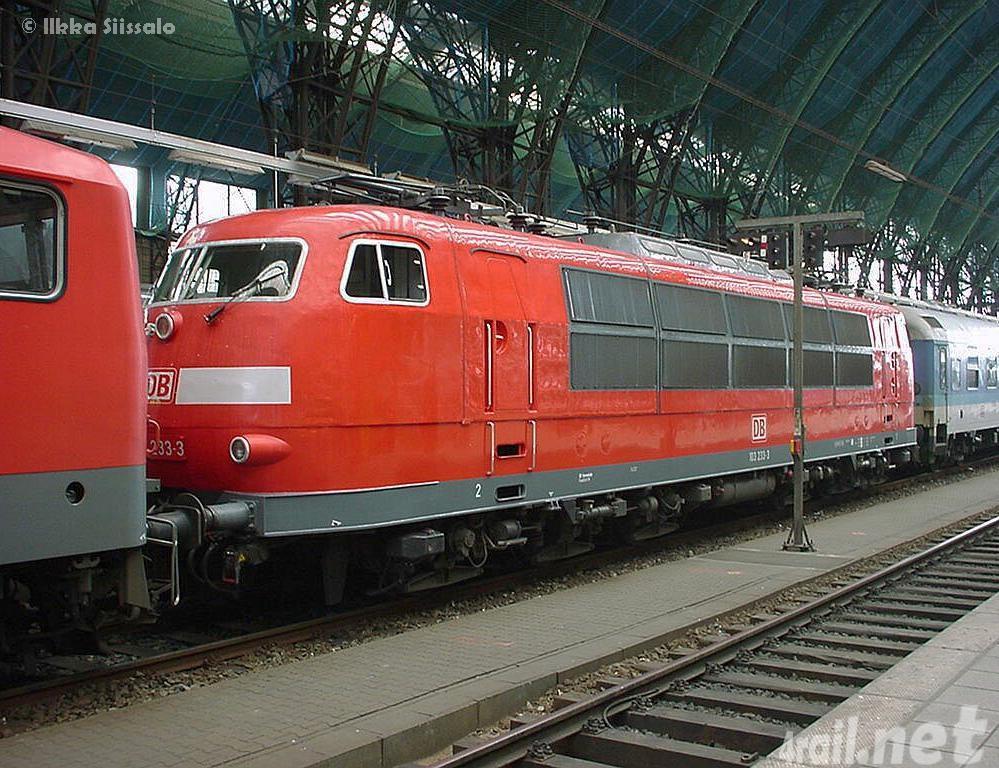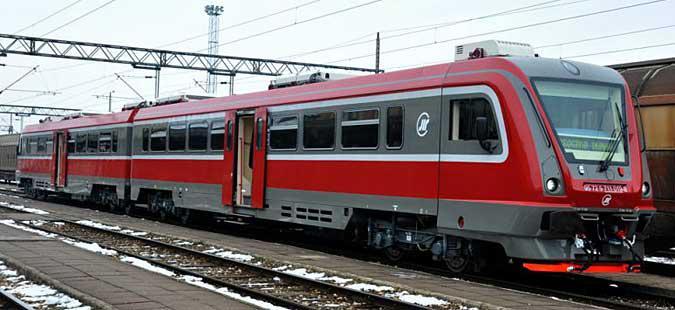The first image is the image on the left, the second image is the image on the right. Evaluate the accuracy of this statement regarding the images: "There are multiple trains in the image on the left.". Is it true? Answer yes or no. No. The first image is the image on the left, the second image is the image on the right. Evaluate the accuracy of this statement regarding the images: "There are two trains in total traveling in opposite direction.". Is it true? Answer yes or no. Yes. 